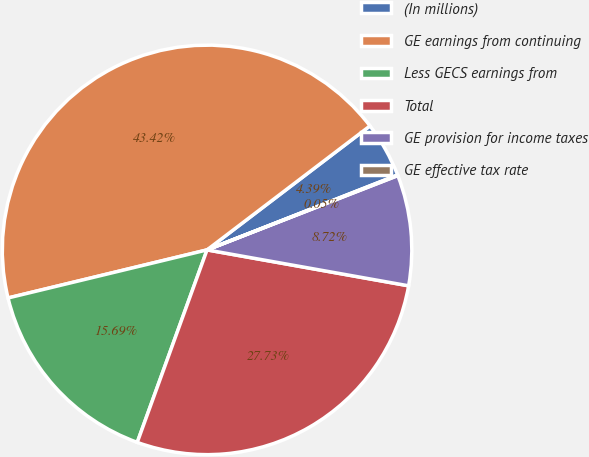Convert chart. <chart><loc_0><loc_0><loc_500><loc_500><pie_chart><fcel>(In millions)<fcel>GE earnings from continuing<fcel>Less GECS earnings from<fcel>Total<fcel>GE provision for income taxes<fcel>GE effective tax rate<nl><fcel>4.39%<fcel>43.42%<fcel>15.69%<fcel>27.73%<fcel>8.72%<fcel>0.05%<nl></chart> 